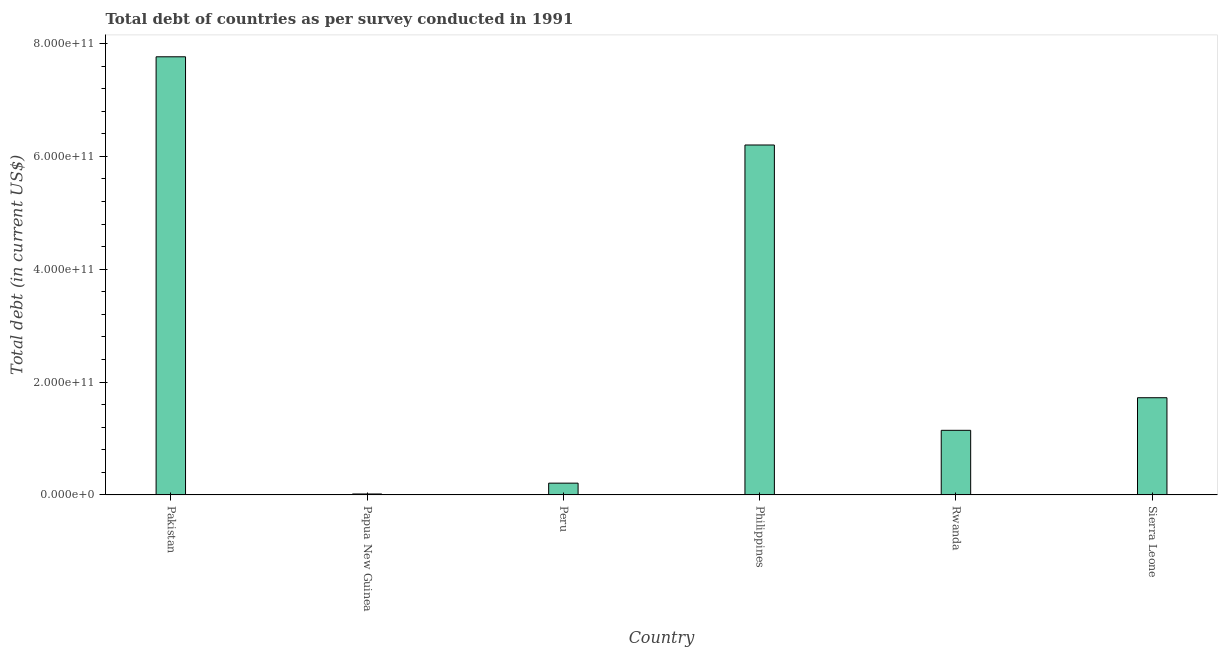What is the title of the graph?
Ensure brevity in your answer.  Total debt of countries as per survey conducted in 1991. What is the label or title of the Y-axis?
Your answer should be very brief. Total debt (in current US$). What is the total debt in Pakistan?
Provide a succinct answer. 7.77e+11. Across all countries, what is the maximum total debt?
Offer a terse response. 7.77e+11. Across all countries, what is the minimum total debt?
Provide a succinct answer. 1.68e+09. In which country was the total debt maximum?
Your response must be concise. Pakistan. In which country was the total debt minimum?
Give a very brief answer. Papua New Guinea. What is the sum of the total debt?
Make the answer very short. 1.71e+12. What is the difference between the total debt in Papua New Guinea and Peru?
Offer a very short reply. -1.92e+1. What is the average total debt per country?
Provide a succinct answer. 2.84e+11. What is the median total debt?
Ensure brevity in your answer.  1.43e+11. What is the ratio of the total debt in Rwanda to that in Sierra Leone?
Your answer should be very brief. 0.67. Is the total debt in Pakistan less than that in Papua New Guinea?
Provide a succinct answer. No. What is the difference between the highest and the second highest total debt?
Provide a succinct answer. 1.56e+11. What is the difference between the highest and the lowest total debt?
Provide a succinct answer. 7.75e+11. In how many countries, is the total debt greater than the average total debt taken over all countries?
Ensure brevity in your answer.  2. How many bars are there?
Offer a terse response. 6. How many countries are there in the graph?
Offer a very short reply. 6. What is the difference between two consecutive major ticks on the Y-axis?
Offer a terse response. 2.00e+11. What is the Total debt (in current US$) in Pakistan?
Your answer should be very brief. 7.77e+11. What is the Total debt (in current US$) of Papua New Guinea?
Your response must be concise. 1.68e+09. What is the Total debt (in current US$) of Peru?
Make the answer very short. 2.09e+1. What is the Total debt (in current US$) of Philippines?
Provide a succinct answer. 6.20e+11. What is the Total debt (in current US$) of Rwanda?
Ensure brevity in your answer.  1.15e+11. What is the Total debt (in current US$) in Sierra Leone?
Keep it short and to the point. 1.72e+11. What is the difference between the Total debt (in current US$) in Pakistan and Papua New Guinea?
Offer a terse response. 7.75e+11. What is the difference between the Total debt (in current US$) in Pakistan and Peru?
Provide a short and direct response. 7.56e+11. What is the difference between the Total debt (in current US$) in Pakistan and Philippines?
Your response must be concise. 1.56e+11. What is the difference between the Total debt (in current US$) in Pakistan and Rwanda?
Make the answer very short. 6.62e+11. What is the difference between the Total debt (in current US$) in Pakistan and Sierra Leone?
Offer a terse response. 6.04e+11. What is the difference between the Total debt (in current US$) in Papua New Guinea and Peru?
Your answer should be very brief. -1.92e+1. What is the difference between the Total debt (in current US$) in Papua New Guinea and Philippines?
Your answer should be very brief. -6.19e+11. What is the difference between the Total debt (in current US$) in Papua New Guinea and Rwanda?
Provide a short and direct response. -1.13e+11. What is the difference between the Total debt (in current US$) in Papua New Guinea and Sierra Leone?
Provide a succinct answer. -1.71e+11. What is the difference between the Total debt (in current US$) in Peru and Philippines?
Ensure brevity in your answer.  -5.99e+11. What is the difference between the Total debt (in current US$) in Peru and Rwanda?
Offer a very short reply. -9.36e+1. What is the difference between the Total debt (in current US$) in Peru and Sierra Leone?
Ensure brevity in your answer.  -1.51e+11. What is the difference between the Total debt (in current US$) in Philippines and Rwanda?
Ensure brevity in your answer.  5.06e+11. What is the difference between the Total debt (in current US$) in Philippines and Sierra Leone?
Your answer should be compact. 4.48e+11. What is the difference between the Total debt (in current US$) in Rwanda and Sierra Leone?
Keep it short and to the point. -5.78e+1. What is the ratio of the Total debt (in current US$) in Pakistan to that in Papua New Guinea?
Offer a terse response. 462.09. What is the ratio of the Total debt (in current US$) in Pakistan to that in Peru?
Offer a very short reply. 37.17. What is the ratio of the Total debt (in current US$) in Pakistan to that in Philippines?
Provide a succinct answer. 1.25. What is the ratio of the Total debt (in current US$) in Pakistan to that in Rwanda?
Offer a terse response. 6.78. What is the ratio of the Total debt (in current US$) in Pakistan to that in Sierra Leone?
Offer a terse response. 4.51. What is the ratio of the Total debt (in current US$) in Papua New Guinea to that in Philippines?
Offer a very short reply. 0. What is the ratio of the Total debt (in current US$) in Papua New Guinea to that in Rwanda?
Your answer should be very brief. 0.01. What is the ratio of the Total debt (in current US$) in Peru to that in Philippines?
Offer a very short reply. 0.03. What is the ratio of the Total debt (in current US$) in Peru to that in Rwanda?
Your response must be concise. 0.18. What is the ratio of the Total debt (in current US$) in Peru to that in Sierra Leone?
Offer a very short reply. 0.12. What is the ratio of the Total debt (in current US$) in Philippines to that in Rwanda?
Your response must be concise. 5.42. What is the ratio of the Total debt (in current US$) in Rwanda to that in Sierra Leone?
Offer a terse response. 0.67. 